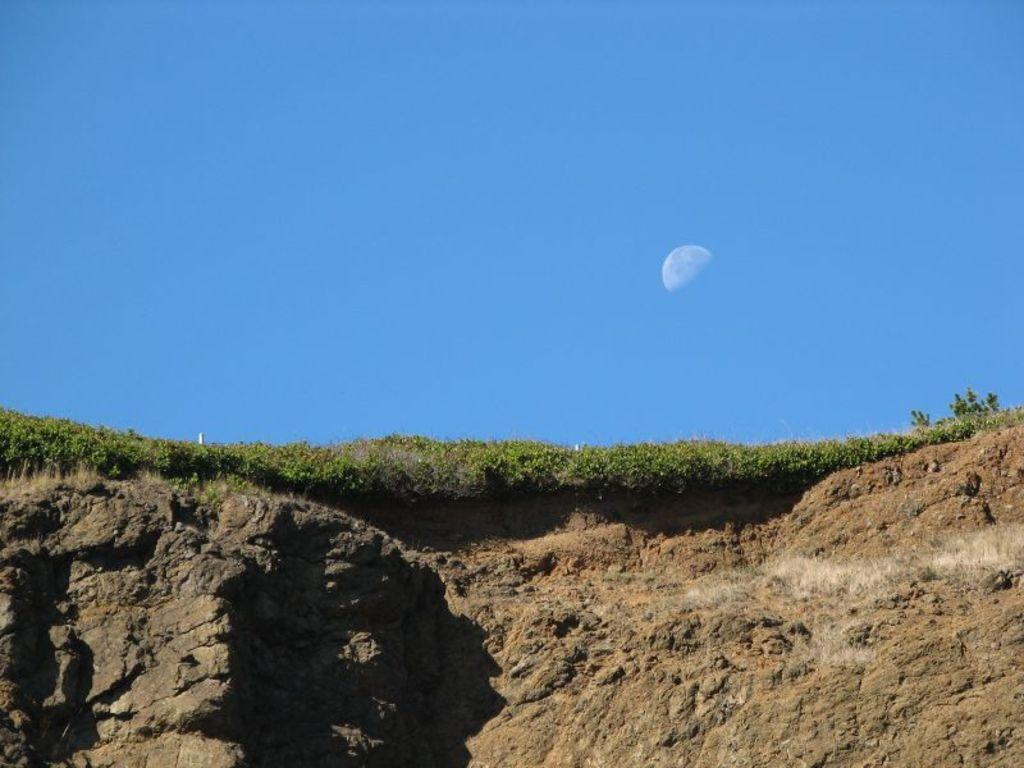What type of vegetation is present in the image? There is grass in the image. What color is the sky in the image? The sky is blue in the image. What celestial body can be seen in the sky? The moon is visible in the sky. What is the tendency of the duck in the image? There is no duck present in the image, so we cannot determine its tendency. What do you believe about the presence of the moon in the image? The presence of the moon in the image is a fact, not a belief. 